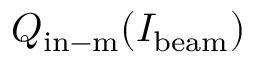<formula> <loc_0><loc_0><loc_500><loc_500>Q _ { i n - m } ( I _ { b e a m } )</formula> 